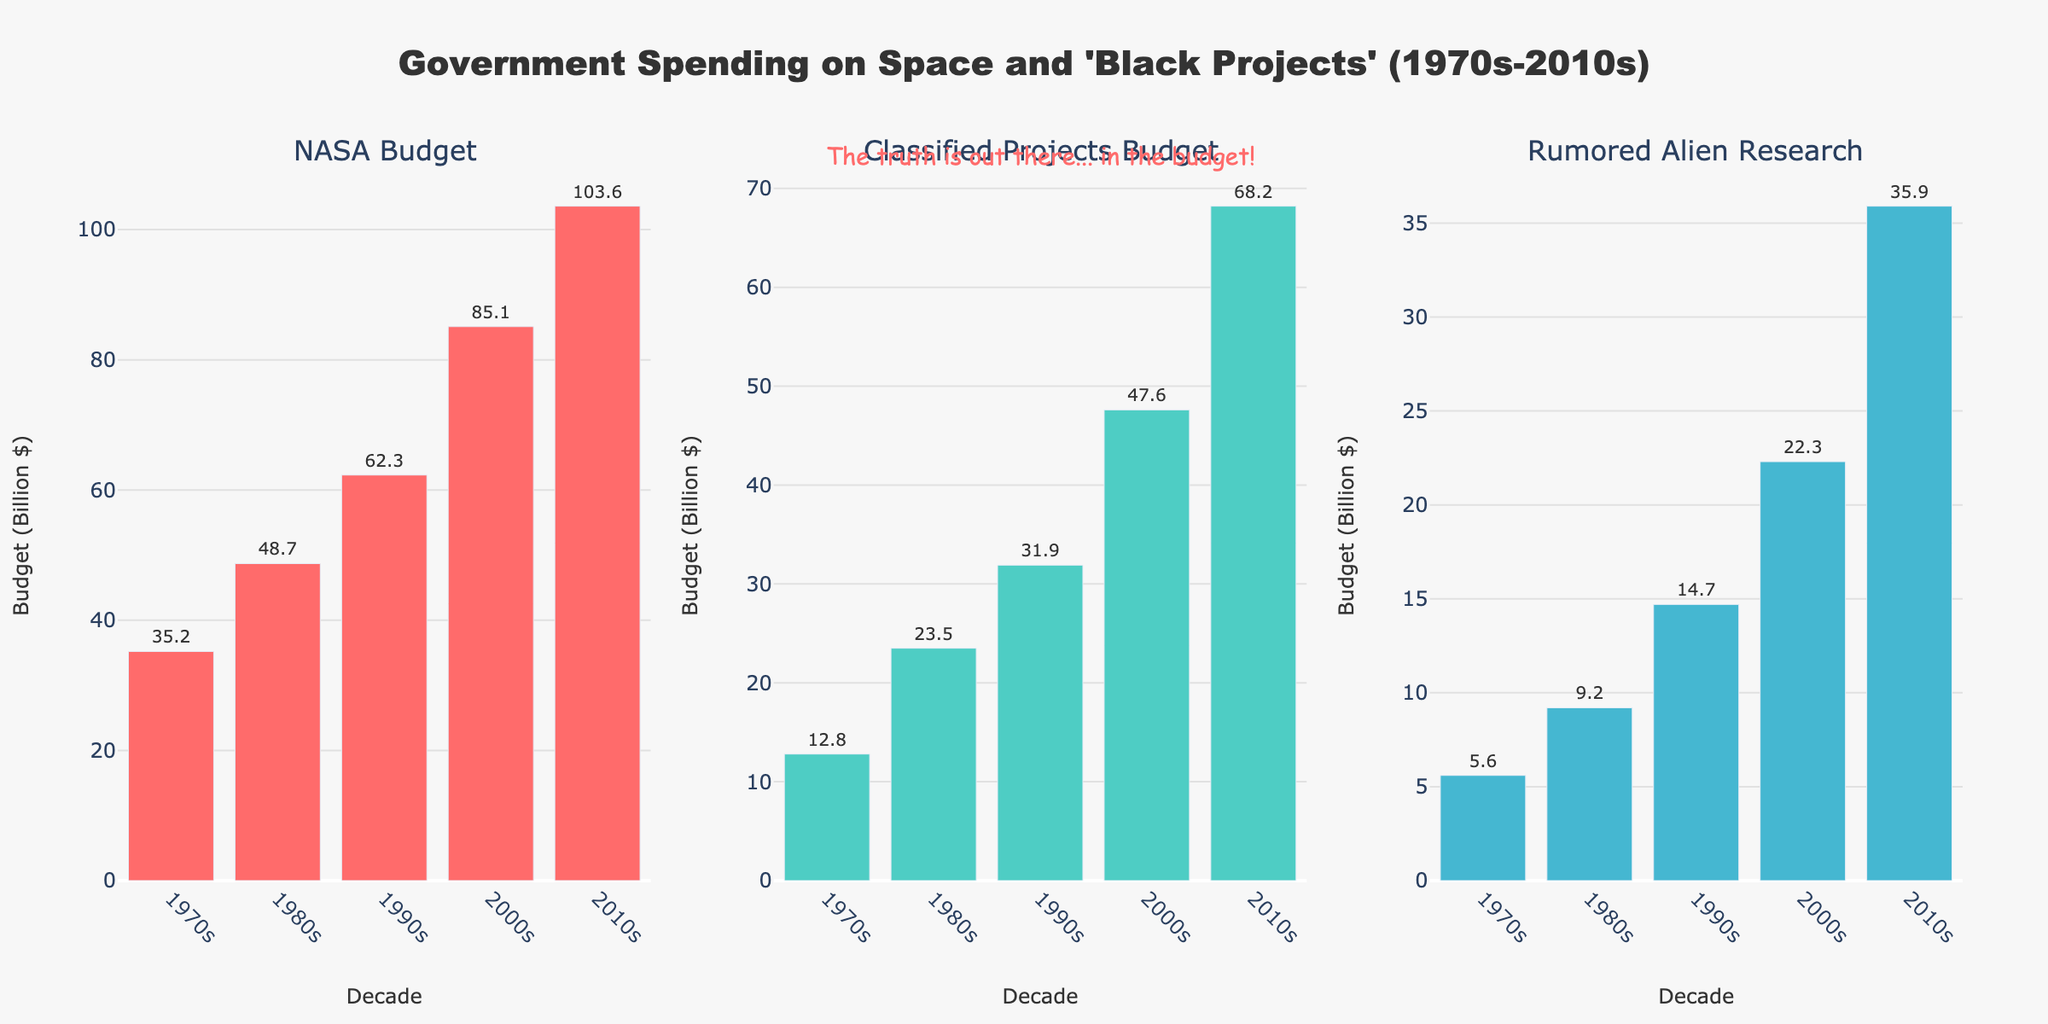What is the title of the figure? The title of the figure is located at the top center of the plot in larger, bold font. It clearly states: "Government Spending on Space and 'Black Projects' (1970s-2010s)"
Answer: Government Spending on Space and 'Black Projects' (1970s-2010s) Which decade had the highest NASA Budget? To find the highest NASA Budget, check the heights of the bars in the NASA Budget subplot. The tallest bar corresponds to the 2010s with a budget of 103.6 Billion $.
Answer: 2010s Compare the budgets for Classified Projects and Rumored Alien Research in the 2000s. Which one is higher and by how much? First, identify the budget for Classified Projects in the 2000s (47.6 Billion $) and for Rumored Alien Research in the same decade (22.3 Billion $). Subtract the lower from the higher (47.6 - 22.3).
Answer: Classified Projects, 25.3 Billion $ What is the average NASA Budget over the five decades? To find the average, sum the NASA Budgets over all decades (35.2 + 48.7 + 62.3 + 85.1 + 103.6) and divide by the number of decades (5). This equals 335.9 / 5.
Answer: 67.18 Billion $ What is the increase in budget for Rumored Alien Research from the 1970s to the 2010s? Identify the budgets in the 1970s (5.6 Billion $) and the 2010s (35.9 Billion $). Subtract the 1970s value from the 2010s value (35.9 - 5.6).
Answer: 30.3 Billion $ Which decade shows the largest budget difference between NASA Budget and Classified Projects Budget? Compute the difference between NASA Budget and Classified Projects Budget for each decade and compare. The decade with the largest difference is the 2010s (103.6 - 68.2 = 35.4 Billion $).
Answer: 2010s How much more did the government spend on NASA compared to Classified Projects in the 1980s? Subtract the Classified Projects Budget in the 1980s (23.5 Billion $) from the NASA Budget in the 1980s (48.7 Billion $).
Answer: 25.2 Billion $ In which decade did the Rumored Alien Research budget see the highest percentage increase? Calculate the percentage increase for each decade relative to the preceding decade: ((New - Old)/Old) * 100. The highest percentage increase occurred from the 1970s (5.6) to the 1980s (9.2), which is ((9.2 - 5.6) / 5.6) * 100 = 64.3%.
Answer: 1980s 